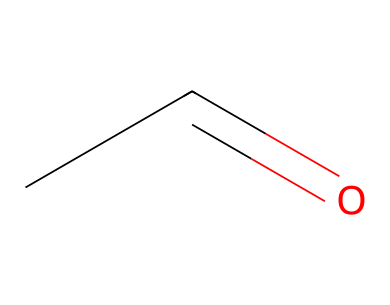What is the molecular formula of this compound? The SMILES "CC=O" indicates the presence of two carbon atoms (C) and one oxygen atom (O), which collectively form the molecular formula C2H4O.
Answer: C2H4O How many hydrogen atoms are present in acetaldehyde? Analyzing the SMILES "CC=O", we see two carbon (C) atoms attached to a total of four hydrogen (H) atoms, leading to a count of four hydrogen atoms.
Answer: four What type of functional group is present in acetaldehyde? The "C=O" part denotes a carbonyl group, which is characteristic of aldehydes, confirming that this compound has an aldehyde functional group.
Answer: aldehyde What bond type connects the carbon atoms in acetaldehyde? The "CC" part of the SMILES indicates a single bond (sigma bond) connecting the two carbon atoms.
Answer: single bond What is the total number of bonds in acetaldehyde? In the structure CC=O, there are three total bonds: one double bond (between C and O) and one single bond (between the two C atoms).
Answer: three Which of the following aldehydes is the simplest? Acetaldehyde is the simplest aldehyde as it contains the smallest carbon chain with the presence of the aldehyde group.
Answer: acetaldehyde Is acetaldehyde a saturated or unsaturated compound? The presence of a double bond with oxygen (C=O) and a carbon-carbon bond indicates that acetaldehyde has unsaturation due to its structure.
Answer: unsaturated 